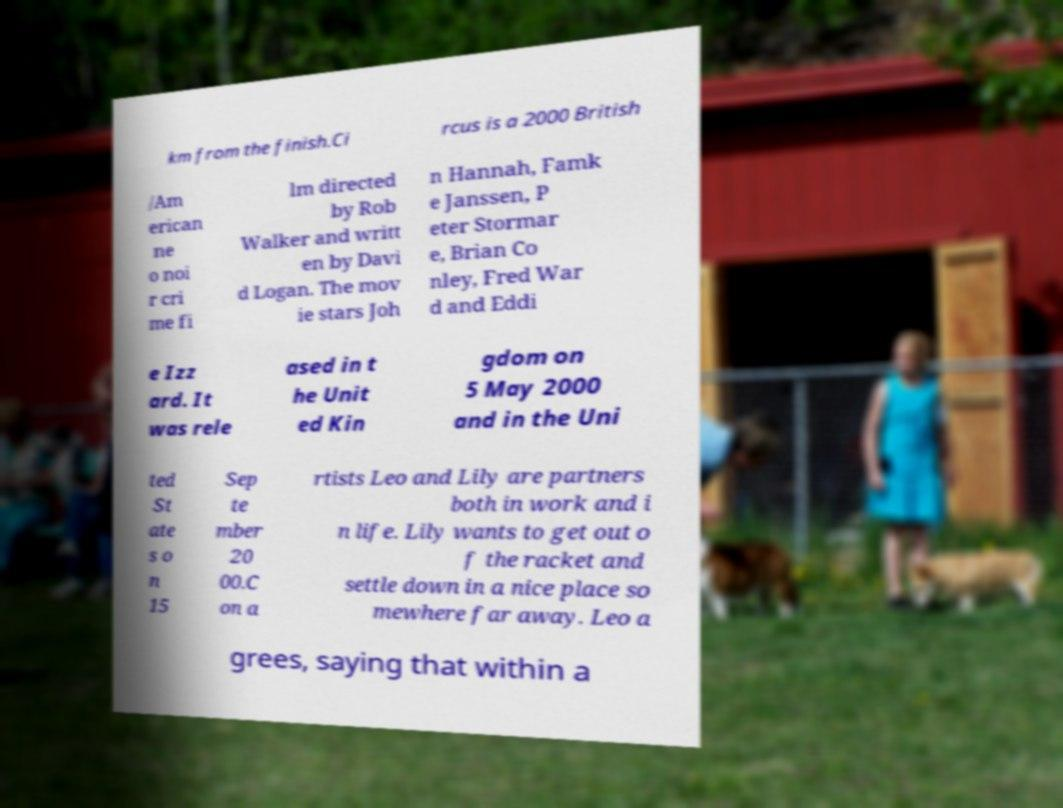Please read and relay the text visible in this image. What does it say? km from the finish.Ci rcus is a 2000 British /Am erican ne o noi r cri me fi lm directed by Rob Walker and writt en by Davi d Logan. The mov ie stars Joh n Hannah, Famk e Janssen, P eter Stormar e, Brian Co nley, Fred War d and Eddi e Izz ard. It was rele ased in t he Unit ed Kin gdom on 5 May 2000 and in the Uni ted St ate s o n 15 Sep te mber 20 00.C on a rtists Leo and Lily are partners both in work and i n life. Lily wants to get out o f the racket and settle down in a nice place so mewhere far away. Leo a grees, saying that within a 